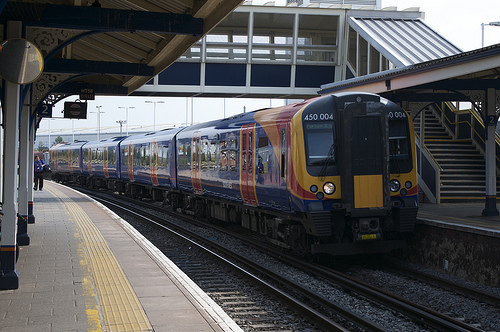Please provide a short description for this region: [0.1, 0.35, 0.19, 0.41]. Within the coordinates [0.1, 0.35, 0.19, 0.41], there is a sign hanging from the ceiling. This signage likely provides directions or information, aiding in navigation and information dissemination within the station. 